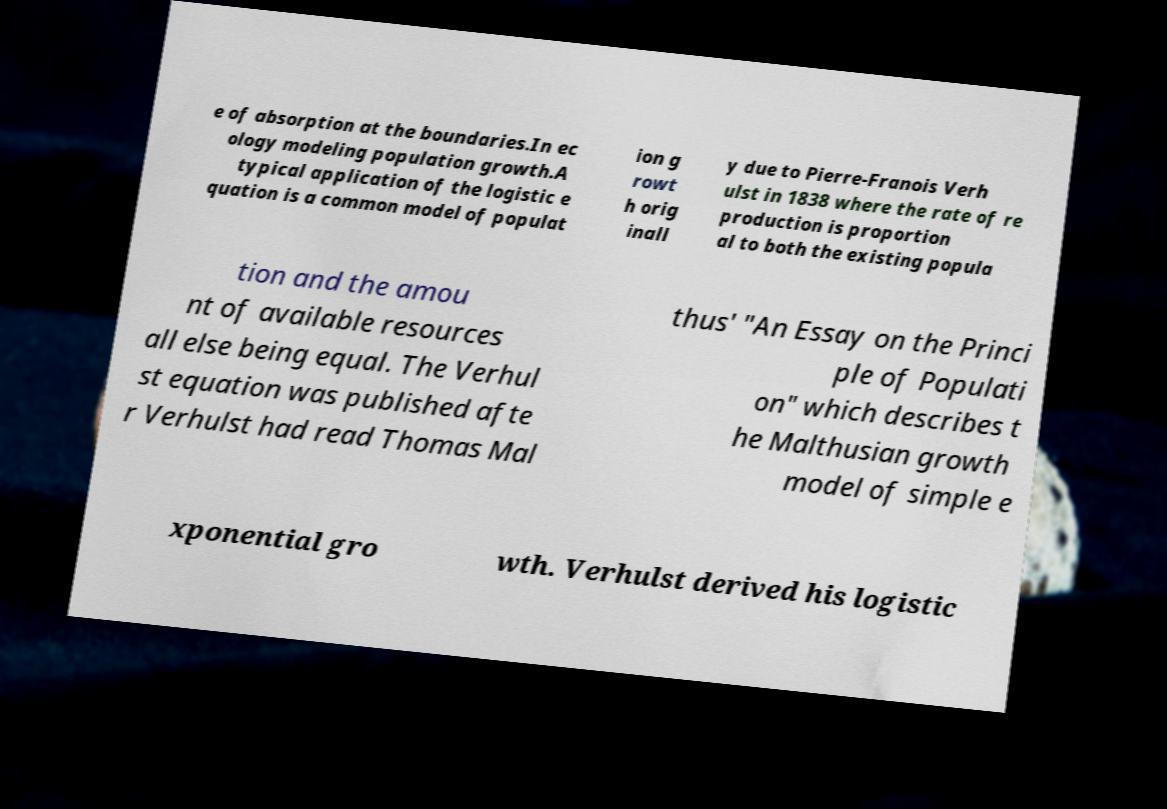Please identify and transcribe the text found in this image. e of absorption at the boundaries.In ec ology modeling population growth.A typical application of the logistic e quation is a common model of populat ion g rowt h orig inall y due to Pierre-Franois Verh ulst in 1838 where the rate of re production is proportion al to both the existing popula tion and the amou nt of available resources all else being equal. The Verhul st equation was published afte r Verhulst had read Thomas Mal thus' "An Essay on the Princi ple of Populati on" which describes t he Malthusian growth model of simple e xponential gro wth. Verhulst derived his logistic 